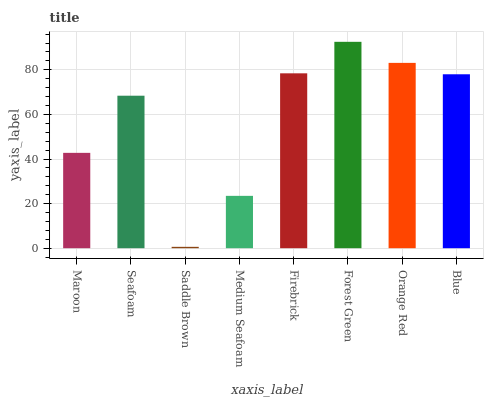Is Saddle Brown the minimum?
Answer yes or no. Yes. Is Forest Green the maximum?
Answer yes or no. Yes. Is Seafoam the minimum?
Answer yes or no. No. Is Seafoam the maximum?
Answer yes or no. No. Is Seafoam greater than Maroon?
Answer yes or no. Yes. Is Maroon less than Seafoam?
Answer yes or no. Yes. Is Maroon greater than Seafoam?
Answer yes or no. No. Is Seafoam less than Maroon?
Answer yes or no. No. Is Blue the high median?
Answer yes or no. Yes. Is Seafoam the low median?
Answer yes or no. Yes. Is Seafoam the high median?
Answer yes or no. No. Is Firebrick the low median?
Answer yes or no. No. 